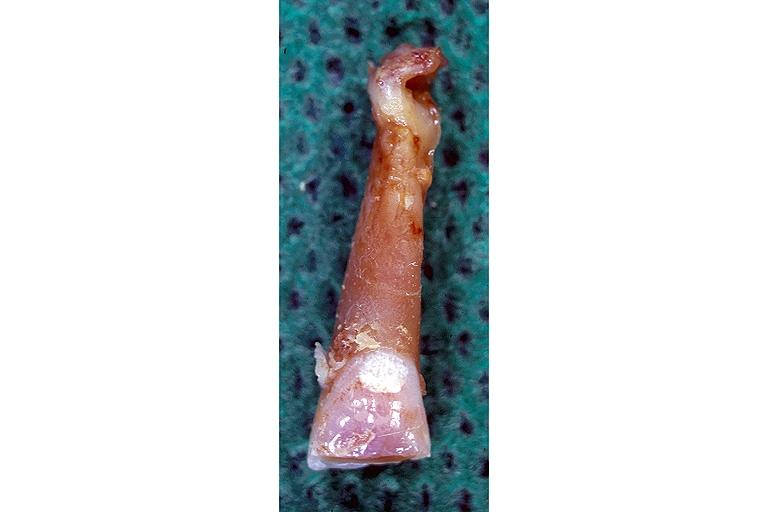does this image show attrition?
Answer the question using a single word or phrase. Yes 